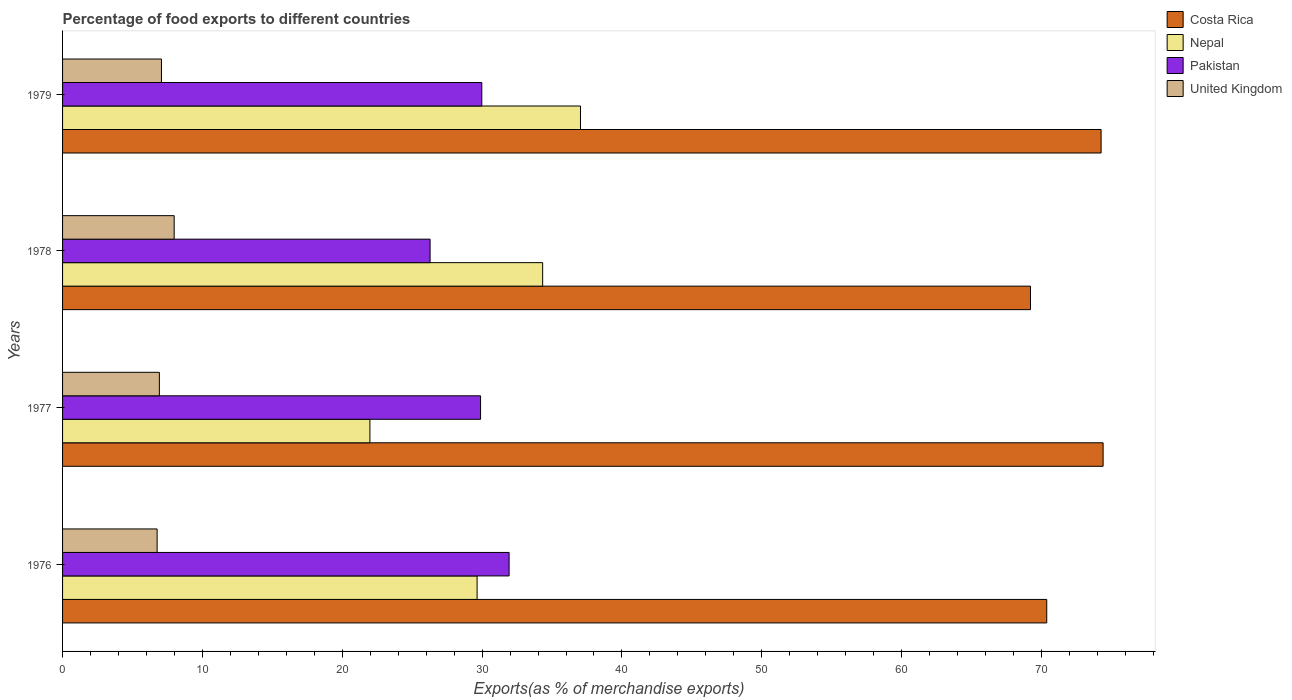How many bars are there on the 1st tick from the top?
Your response must be concise. 4. How many bars are there on the 4th tick from the bottom?
Offer a very short reply. 4. What is the label of the 4th group of bars from the top?
Provide a succinct answer. 1976. In how many cases, is the number of bars for a given year not equal to the number of legend labels?
Offer a very short reply. 0. What is the percentage of exports to different countries in Nepal in 1979?
Your answer should be compact. 37.03. Across all years, what is the maximum percentage of exports to different countries in Nepal?
Offer a very short reply. 37.03. Across all years, what is the minimum percentage of exports to different countries in Costa Rica?
Ensure brevity in your answer.  69.21. In which year was the percentage of exports to different countries in Nepal maximum?
Give a very brief answer. 1979. In which year was the percentage of exports to different countries in Pakistan minimum?
Your answer should be compact. 1978. What is the total percentage of exports to different countries in Nepal in the graph?
Offer a terse response. 122.98. What is the difference between the percentage of exports to different countries in Nepal in 1978 and that in 1979?
Your answer should be very brief. -2.7. What is the difference between the percentage of exports to different countries in Costa Rica in 1979 and the percentage of exports to different countries in Pakistan in 1977?
Offer a very short reply. 44.37. What is the average percentage of exports to different countries in United Kingdom per year?
Keep it short and to the point. 7.18. In the year 1979, what is the difference between the percentage of exports to different countries in Costa Rica and percentage of exports to different countries in Pakistan?
Provide a succinct answer. 44.28. In how many years, is the percentage of exports to different countries in Nepal greater than 22 %?
Offer a very short reply. 3. What is the ratio of the percentage of exports to different countries in United Kingdom in 1976 to that in 1978?
Provide a short and direct response. 0.85. Is the difference between the percentage of exports to different countries in Costa Rica in 1978 and 1979 greater than the difference between the percentage of exports to different countries in Pakistan in 1978 and 1979?
Your response must be concise. No. What is the difference between the highest and the second highest percentage of exports to different countries in Pakistan?
Keep it short and to the point. 1.95. What is the difference between the highest and the lowest percentage of exports to different countries in Pakistan?
Keep it short and to the point. 5.65. In how many years, is the percentage of exports to different countries in United Kingdom greater than the average percentage of exports to different countries in United Kingdom taken over all years?
Offer a terse response. 1. What does the 3rd bar from the top in 1978 represents?
Your response must be concise. Nepal. What does the 2nd bar from the bottom in 1977 represents?
Ensure brevity in your answer.  Nepal. Is it the case that in every year, the sum of the percentage of exports to different countries in Nepal and percentage of exports to different countries in Pakistan is greater than the percentage of exports to different countries in United Kingdom?
Provide a short and direct response. Yes. How many bars are there?
Keep it short and to the point. 16. Are all the bars in the graph horizontal?
Offer a terse response. Yes. What is the difference between two consecutive major ticks on the X-axis?
Your answer should be very brief. 10. Does the graph contain any zero values?
Offer a very short reply. No. Does the graph contain grids?
Keep it short and to the point. No. What is the title of the graph?
Provide a succinct answer. Percentage of food exports to different countries. Does "Malawi" appear as one of the legend labels in the graph?
Keep it short and to the point. No. What is the label or title of the X-axis?
Your response must be concise. Exports(as % of merchandise exports). What is the Exports(as % of merchandise exports) in Costa Rica in 1976?
Provide a short and direct response. 70.37. What is the Exports(as % of merchandise exports) in Nepal in 1976?
Provide a succinct answer. 29.64. What is the Exports(as % of merchandise exports) in Pakistan in 1976?
Your response must be concise. 31.93. What is the Exports(as % of merchandise exports) of United Kingdom in 1976?
Your response must be concise. 6.76. What is the Exports(as % of merchandise exports) of Costa Rica in 1977?
Provide a short and direct response. 74.41. What is the Exports(as % of merchandise exports) of Nepal in 1977?
Ensure brevity in your answer.  21.98. What is the Exports(as % of merchandise exports) of Pakistan in 1977?
Ensure brevity in your answer.  29.89. What is the Exports(as % of merchandise exports) in United Kingdom in 1977?
Provide a short and direct response. 6.92. What is the Exports(as % of merchandise exports) of Costa Rica in 1978?
Your answer should be very brief. 69.21. What is the Exports(as % of merchandise exports) in Nepal in 1978?
Your answer should be compact. 34.33. What is the Exports(as % of merchandise exports) of Pakistan in 1978?
Provide a short and direct response. 26.28. What is the Exports(as % of merchandise exports) in United Kingdom in 1978?
Your answer should be very brief. 7.98. What is the Exports(as % of merchandise exports) of Costa Rica in 1979?
Offer a very short reply. 74.26. What is the Exports(as % of merchandise exports) in Nepal in 1979?
Keep it short and to the point. 37.03. What is the Exports(as % of merchandise exports) in Pakistan in 1979?
Provide a succinct answer. 29.98. What is the Exports(as % of merchandise exports) of United Kingdom in 1979?
Keep it short and to the point. 7.07. Across all years, what is the maximum Exports(as % of merchandise exports) of Costa Rica?
Ensure brevity in your answer.  74.41. Across all years, what is the maximum Exports(as % of merchandise exports) in Nepal?
Your response must be concise. 37.03. Across all years, what is the maximum Exports(as % of merchandise exports) of Pakistan?
Your answer should be compact. 31.93. Across all years, what is the maximum Exports(as % of merchandise exports) in United Kingdom?
Provide a short and direct response. 7.98. Across all years, what is the minimum Exports(as % of merchandise exports) in Costa Rica?
Offer a very short reply. 69.21. Across all years, what is the minimum Exports(as % of merchandise exports) in Nepal?
Offer a terse response. 21.98. Across all years, what is the minimum Exports(as % of merchandise exports) in Pakistan?
Keep it short and to the point. 26.28. Across all years, what is the minimum Exports(as % of merchandise exports) of United Kingdom?
Give a very brief answer. 6.76. What is the total Exports(as % of merchandise exports) of Costa Rica in the graph?
Ensure brevity in your answer.  288.25. What is the total Exports(as % of merchandise exports) in Nepal in the graph?
Your answer should be compact. 122.98. What is the total Exports(as % of merchandise exports) of Pakistan in the graph?
Keep it short and to the point. 118.08. What is the total Exports(as % of merchandise exports) in United Kingdom in the graph?
Make the answer very short. 28.74. What is the difference between the Exports(as % of merchandise exports) in Costa Rica in 1976 and that in 1977?
Your response must be concise. -4.03. What is the difference between the Exports(as % of merchandise exports) in Nepal in 1976 and that in 1977?
Your response must be concise. 7.66. What is the difference between the Exports(as % of merchandise exports) in Pakistan in 1976 and that in 1977?
Provide a short and direct response. 2.04. What is the difference between the Exports(as % of merchandise exports) of United Kingdom in 1976 and that in 1977?
Provide a succinct answer. -0.16. What is the difference between the Exports(as % of merchandise exports) of Costa Rica in 1976 and that in 1978?
Ensure brevity in your answer.  1.16. What is the difference between the Exports(as % of merchandise exports) in Nepal in 1976 and that in 1978?
Offer a very short reply. -4.69. What is the difference between the Exports(as % of merchandise exports) in Pakistan in 1976 and that in 1978?
Make the answer very short. 5.65. What is the difference between the Exports(as % of merchandise exports) in United Kingdom in 1976 and that in 1978?
Your answer should be compact. -1.22. What is the difference between the Exports(as % of merchandise exports) of Costa Rica in 1976 and that in 1979?
Make the answer very short. -3.89. What is the difference between the Exports(as % of merchandise exports) of Nepal in 1976 and that in 1979?
Your response must be concise. -7.39. What is the difference between the Exports(as % of merchandise exports) in Pakistan in 1976 and that in 1979?
Provide a short and direct response. 1.95. What is the difference between the Exports(as % of merchandise exports) of United Kingdom in 1976 and that in 1979?
Offer a very short reply. -0.31. What is the difference between the Exports(as % of merchandise exports) of Costa Rica in 1977 and that in 1978?
Offer a very short reply. 5.19. What is the difference between the Exports(as % of merchandise exports) in Nepal in 1977 and that in 1978?
Make the answer very short. -12.35. What is the difference between the Exports(as % of merchandise exports) of Pakistan in 1977 and that in 1978?
Make the answer very short. 3.61. What is the difference between the Exports(as % of merchandise exports) in United Kingdom in 1977 and that in 1978?
Keep it short and to the point. -1.06. What is the difference between the Exports(as % of merchandise exports) of Costa Rica in 1977 and that in 1979?
Keep it short and to the point. 0.14. What is the difference between the Exports(as % of merchandise exports) of Nepal in 1977 and that in 1979?
Offer a terse response. -15.06. What is the difference between the Exports(as % of merchandise exports) in Pakistan in 1977 and that in 1979?
Your answer should be very brief. -0.09. What is the difference between the Exports(as % of merchandise exports) of United Kingdom in 1977 and that in 1979?
Your answer should be compact. -0.15. What is the difference between the Exports(as % of merchandise exports) of Costa Rica in 1978 and that in 1979?
Your answer should be compact. -5.05. What is the difference between the Exports(as % of merchandise exports) in Nepal in 1978 and that in 1979?
Offer a terse response. -2.7. What is the difference between the Exports(as % of merchandise exports) of Pakistan in 1978 and that in 1979?
Offer a terse response. -3.7. What is the difference between the Exports(as % of merchandise exports) of United Kingdom in 1978 and that in 1979?
Provide a succinct answer. 0.91. What is the difference between the Exports(as % of merchandise exports) of Costa Rica in 1976 and the Exports(as % of merchandise exports) of Nepal in 1977?
Ensure brevity in your answer.  48.4. What is the difference between the Exports(as % of merchandise exports) in Costa Rica in 1976 and the Exports(as % of merchandise exports) in Pakistan in 1977?
Your answer should be very brief. 40.49. What is the difference between the Exports(as % of merchandise exports) of Costa Rica in 1976 and the Exports(as % of merchandise exports) of United Kingdom in 1977?
Provide a short and direct response. 63.45. What is the difference between the Exports(as % of merchandise exports) in Nepal in 1976 and the Exports(as % of merchandise exports) in Pakistan in 1977?
Provide a short and direct response. -0.25. What is the difference between the Exports(as % of merchandise exports) in Nepal in 1976 and the Exports(as % of merchandise exports) in United Kingdom in 1977?
Offer a very short reply. 22.72. What is the difference between the Exports(as % of merchandise exports) of Pakistan in 1976 and the Exports(as % of merchandise exports) of United Kingdom in 1977?
Offer a terse response. 25.01. What is the difference between the Exports(as % of merchandise exports) of Costa Rica in 1976 and the Exports(as % of merchandise exports) of Nepal in 1978?
Give a very brief answer. 36.04. What is the difference between the Exports(as % of merchandise exports) of Costa Rica in 1976 and the Exports(as % of merchandise exports) of Pakistan in 1978?
Your answer should be very brief. 44.09. What is the difference between the Exports(as % of merchandise exports) in Costa Rica in 1976 and the Exports(as % of merchandise exports) in United Kingdom in 1978?
Provide a short and direct response. 62.39. What is the difference between the Exports(as % of merchandise exports) of Nepal in 1976 and the Exports(as % of merchandise exports) of Pakistan in 1978?
Ensure brevity in your answer.  3.36. What is the difference between the Exports(as % of merchandise exports) in Nepal in 1976 and the Exports(as % of merchandise exports) in United Kingdom in 1978?
Provide a short and direct response. 21.66. What is the difference between the Exports(as % of merchandise exports) in Pakistan in 1976 and the Exports(as % of merchandise exports) in United Kingdom in 1978?
Offer a very short reply. 23.95. What is the difference between the Exports(as % of merchandise exports) in Costa Rica in 1976 and the Exports(as % of merchandise exports) in Nepal in 1979?
Keep it short and to the point. 33.34. What is the difference between the Exports(as % of merchandise exports) in Costa Rica in 1976 and the Exports(as % of merchandise exports) in Pakistan in 1979?
Your answer should be very brief. 40.4. What is the difference between the Exports(as % of merchandise exports) in Costa Rica in 1976 and the Exports(as % of merchandise exports) in United Kingdom in 1979?
Provide a succinct answer. 63.3. What is the difference between the Exports(as % of merchandise exports) in Nepal in 1976 and the Exports(as % of merchandise exports) in Pakistan in 1979?
Make the answer very short. -0.34. What is the difference between the Exports(as % of merchandise exports) of Nepal in 1976 and the Exports(as % of merchandise exports) of United Kingdom in 1979?
Offer a very short reply. 22.57. What is the difference between the Exports(as % of merchandise exports) in Pakistan in 1976 and the Exports(as % of merchandise exports) in United Kingdom in 1979?
Your response must be concise. 24.86. What is the difference between the Exports(as % of merchandise exports) in Costa Rica in 1977 and the Exports(as % of merchandise exports) in Nepal in 1978?
Ensure brevity in your answer.  40.08. What is the difference between the Exports(as % of merchandise exports) in Costa Rica in 1977 and the Exports(as % of merchandise exports) in Pakistan in 1978?
Ensure brevity in your answer.  48.12. What is the difference between the Exports(as % of merchandise exports) in Costa Rica in 1977 and the Exports(as % of merchandise exports) in United Kingdom in 1978?
Your answer should be very brief. 66.42. What is the difference between the Exports(as % of merchandise exports) of Nepal in 1977 and the Exports(as % of merchandise exports) of Pakistan in 1978?
Your answer should be very brief. -4.3. What is the difference between the Exports(as % of merchandise exports) in Nepal in 1977 and the Exports(as % of merchandise exports) in United Kingdom in 1978?
Make the answer very short. 14. What is the difference between the Exports(as % of merchandise exports) of Pakistan in 1977 and the Exports(as % of merchandise exports) of United Kingdom in 1978?
Make the answer very short. 21.91. What is the difference between the Exports(as % of merchandise exports) in Costa Rica in 1977 and the Exports(as % of merchandise exports) in Nepal in 1979?
Your response must be concise. 37.37. What is the difference between the Exports(as % of merchandise exports) of Costa Rica in 1977 and the Exports(as % of merchandise exports) of Pakistan in 1979?
Provide a short and direct response. 44.43. What is the difference between the Exports(as % of merchandise exports) in Costa Rica in 1977 and the Exports(as % of merchandise exports) in United Kingdom in 1979?
Ensure brevity in your answer.  67.33. What is the difference between the Exports(as % of merchandise exports) of Nepal in 1977 and the Exports(as % of merchandise exports) of Pakistan in 1979?
Offer a very short reply. -8. What is the difference between the Exports(as % of merchandise exports) in Nepal in 1977 and the Exports(as % of merchandise exports) in United Kingdom in 1979?
Make the answer very short. 14.9. What is the difference between the Exports(as % of merchandise exports) in Pakistan in 1977 and the Exports(as % of merchandise exports) in United Kingdom in 1979?
Provide a succinct answer. 22.82. What is the difference between the Exports(as % of merchandise exports) in Costa Rica in 1978 and the Exports(as % of merchandise exports) in Nepal in 1979?
Keep it short and to the point. 32.18. What is the difference between the Exports(as % of merchandise exports) of Costa Rica in 1978 and the Exports(as % of merchandise exports) of Pakistan in 1979?
Provide a short and direct response. 39.23. What is the difference between the Exports(as % of merchandise exports) in Costa Rica in 1978 and the Exports(as % of merchandise exports) in United Kingdom in 1979?
Ensure brevity in your answer.  62.14. What is the difference between the Exports(as % of merchandise exports) in Nepal in 1978 and the Exports(as % of merchandise exports) in Pakistan in 1979?
Provide a short and direct response. 4.35. What is the difference between the Exports(as % of merchandise exports) of Nepal in 1978 and the Exports(as % of merchandise exports) of United Kingdom in 1979?
Make the answer very short. 27.26. What is the difference between the Exports(as % of merchandise exports) in Pakistan in 1978 and the Exports(as % of merchandise exports) in United Kingdom in 1979?
Offer a very short reply. 19.21. What is the average Exports(as % of merchandise exports) in Costa Rica per year?
Provide a succinct answer. 72.06. What is the average Exports(as % of merchandise exports) in Nepal per year?
Provide a short and direct response. 30.75. What is the average Exports(as % of merchandise exports) in Pakistan per year?
Offer a very short reply. 29.52. What is the average Exports(as % of merchandise exports) of United Kingdom per year?
Offer a terse response. 7.18. In the year 1976, what is the difference between the Exports(as % of merchandise exports) in Costa Rica and Exports(as % of merchandise exports) in Nepal?
Offer a terse response. 40.73. In the year 1976, what is the difference between the Exports(as % of merchandise exports) of Costa Rica and Exports(as % of merchandise exports) of Pakistan?
Your response must be concise. 38.44. In the year 1976, what is the difference between the Exports(as % of merchandise exports) in Costa Rica and Exports(as % of merchandise exports) in United Kingdom?
Your answer should be very brief. 63.61. In the year 1976, what is the difference between the Exports(as % of merchandise exports) in Nepal and Exports(as % of merchandise exports) in Pakistan?
Offer a terse response. -2.29. In the year 1976, what is the difference between the Exports(as % of merchandise exports) of Nepal and Exports(as % of merchandise exports) of United Kingdom?
Provide a short and direct response. 22.88. In the year 1976, what is the difference between the Exports(as % of merchandise exports) in Pakistan and Exports(as % of merchandise exports) in United Kingdom?
Keep it short and to the point. 25.17. In the year 1977, what is the difference between the Exports(as % of merchandise exports) in Costa Rica and Exports(as % of merchandise exports) in Nepal?
Keep it short and to the point. 52.43. In the year 1977, what is the difference between the Exports(as % of merchandise exports) in Costa Rica and Exports(as % of merchandise exports) in Pakistan?
Keep it short and to the point. 44.52. In the year 1977, what is the difference between the Exports(as % of merchandise exports) in Costa Rica and Exports(as % of merchandise exports) in United Kingdom?
Ensure brevity in your answer.  67.48. In the year 1977, what is the difference between the Exports(as % of merchandise exports) of Nepal and Exports(as % of merchandise exports) of Pakistan?
Your answer should be very brief. -7.91. In the year 1977, what is the difference between the Exports(as % of merchandise exports) of Nepal and Exports(as % of merchandise exports) of United Kingdom?
Your answer should be compact. 15.05. In the year 1977, what is the difference between the Exports(as % of merchandise exports) in Pakistan and Exports(as % of merchandise exports) in United Kingdom?
Ensure brevity in your answer.  22.97. In the year 1978, what is the difference between the Exports(as % of merchandise exports) in Costa Rica and Exports(as % of merchandise exports) in Nepal?
Your answer should be compact. 34.88. In the year 1978, what is the difference between the Exports(as % of merchandise exports) of Costa Rica and Exports(as % of merchandise exports) of Pakistan?
Make the answer very short. 42.93. In the year 1978, what is the difference between the Exports(as % of merchandise exports) in Costa Rica and Exports(as % of merchandise exports) in United Kingdom?
Your response must be concise. 61.23. In the year 1978, what is the difference between the Exports(as % of merchandise exports) in Nepal and Exports(as % of merchandise exports) in Pakistan?
Give a very brief answer. 8.05. In the year 1978, what is the difference between the Exports(as % of merchandise exports) in Nepal and Exports(as % of merchandise exports) in United Kingdom?
Keep it short and to the point. 26.35. In the year 1978, what is the difference between the Exports(as % of merchandise exports) of Pakistan and Exports(as % of merchandise exports) of United Kingdom?
Offer a very short reply. 18.3. In the year 1979, what is the difference between the Exports(as % of merchandise exports) of Costa Rica and Exports(as % of merchandise exports) of Nepal?
Keep it short and to the point. 37.23. In the year 1979, what is the difference between the Exports(as % of merchandise exports) in Costa Rica and Exports(as % of merchandise exports) in Pakistan?
Offer a very short reply. 44.28. In the year 1979, what is the difference between the Exports(as % of merchandise exports) of Costa Rica and Exports(as % of merchandise exports) of United Kingdom?
Provide a succinct answer. 67.19. In the year 1979, what is the difference between the Exports(as % of merchandise exports) in Nepal and Exports(as % of merchandise exports) in Pakistan?
Offer a terse response. 7.06. In the year 1979, what is the difference between the Exports(as % of merchandise exports) in Nepal and Exports(as % of merchandise exports) in United Kingdom?
Offer a terse response. 29.96. In the year 1979, what is the difference between the Exports(as % of merchandise exports) in Pakistan and Exports(as % of merchandise exports) in United Kingdom?
Provide a succinct answer. 22.91. What is the ratio of the Exports(as % of merchandise exports) of Costa Rica in 1976 to that in 1977?
Your answer should be very brief. 0.95. What is the ratio of the Exports(as % of merchandise exports) of Nepal in 1976 to that in 1977?
Provide a short and direct response. 1.35. What is the ratio of the Exports(as % of merchandise exports) in Pakistan in 1976 to that in 1977?
Your response must be concise. 1.07. What is the ratio of the Exports(as % of merchandise exports) of United Kingdom in 1976 to that in 1977?
Your answer should be very brief. 0.98. What is the ratio of the Exports(as % of merchandise exports) in Costa Rica in 1976 to that in 1978?
Your answer should be very brief. 1.02. What is the ratio of the Exports(as % of merchandise exports) in Nepal in 1976 to that in 1978?
Your answer should be compact. 0.86. What is the ratio of the Exports(as % of merchandise exports) of Pakistan in 1976 to that in 1978?
Provide a short and direct response. 1.22. What is the ratio of the Exports(as % of merchandise exports) of United Kingdom in 1976 to that in 1978?
Your answer should be very brief. 0.85. What is the ratio of the Exports(as % of merchandise exports) in Costa Rica in 1976 to that in 1979?
Make the answer very short. 0.95. What is the ratio of the Exports(as % of merchandise exports) of Nepal in 1976 to that in 1979?
Ensure brevity in your answer.  0.8. What is the ratio of the Exports(as % of merchandise exports) of Pakistan in 1976 to that in 1979?
Your answer should be compact. 1.07. What is the ratio of the Exports(as % of merchandise exports) in United Kingdom in 1976 to that in 1979?
Give a very brief answer. 0.96. What is the ratio of the Exports(as % of merchandise exports) in Costa Rica in 1977 to that in 1978?
Provide a succinct answer. 1.07. What is the ratio of the Exports(as % of merchandise exports) in Nepal in 1977 to that in 1978?
Keep it short and to the point. 0.64. What is the ratio of the Exports(as % of merchandise exports) of Pakistan in 1977 to that in 1978?
Provide a succinct answer. 1.14. What is the ratio of the Exports(as % of merchandise exports) of United Kingdom in 1977 to that in 1978?
Provide a succinct answer. 0.87. What is the ratio of the Exports(as % of merchandise exports) of Nepal in 1977 to that in 1979?
Your response must be concise. 0.59. What is the ratio of the Exports(as % of merchandise exports) of United Kingdom in 1977 to that in 1979?
Make the answer very short. 0.98. What is the ratio of the Exports(as % of merchandise exports) in Costa Rica in 1978 to that in 1979?
Provide a succinct answer. 0.93. What is the ratio of the Exports(as % of merchandise exports) in Nepal in 1978 to that in 1979?
Offer a very short reply. 0.93. What is the ratio of the Exports(as % of merchandise exports) in Pakistan in 1978 to that in 1979?
Offer a very short reply. 0.88. What is the ratio of the Exports(as % of merchandise exports) in United Kingdom in 1978 to that in 1979?
Make the answer very short. 1.13. What is the difference between the highest and the second highest Exports(as % of merchandise exports) of Costa Rica?
Ensure brevity in your answer.  0.14. What is the difference between the highest and the second highest Exports(as % of merchandise exports) of Nepal?
Your response must be concise. 2.7. What is the difference between the highest and the second highest Exports(as % of merchandise exports) of Pakistan?
Give a very brief answer. 1.95. What is the difference between the highest and the second highest Exports(as % of merchandise exports) in United Kingdom?
Provide a succinct answer. 0.91. What is the difference between the highest and the lowest Exports(as % of merchandise exports) of Costa Rica?
Your answer should be very brief. 5.19. What is the difference between the highest and the lowest Exports(as % of merchandise exports) in Nepal?
Keep it short and to the point. 15.06. What is the difference between the highest and the lowest Exports(as % of merchandise exports) in Pakistan?
Keep it short and to the point. 5.65. What is the difference between the highest and the lowest Exports(as % of merchandise exports) of United Kingdom?
Your answer should be compact. 1.22. 